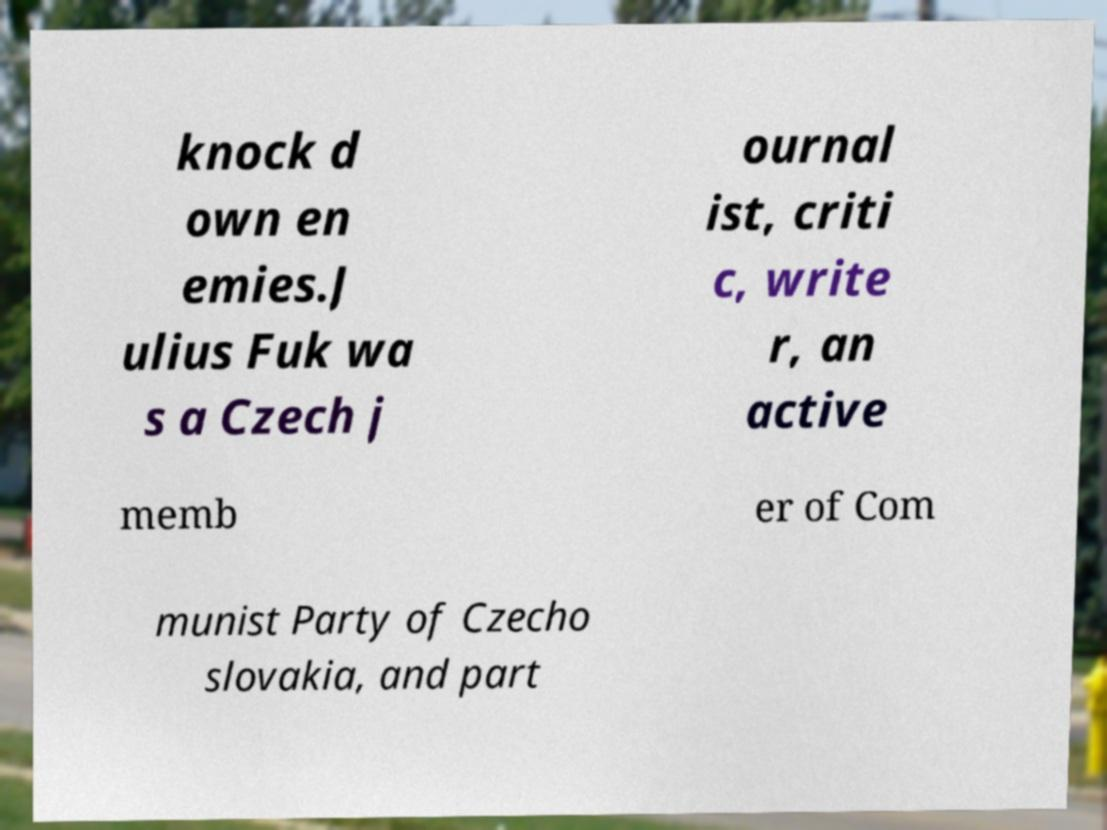For documentation purposes, I need the text within this image transcribed. Could you provide that? knock d own en emies.J ulius Fuk wa s a Czech j ournal ist, criti c, write r, an active memb er of Com munist Party of Czecho slovakia, and part 